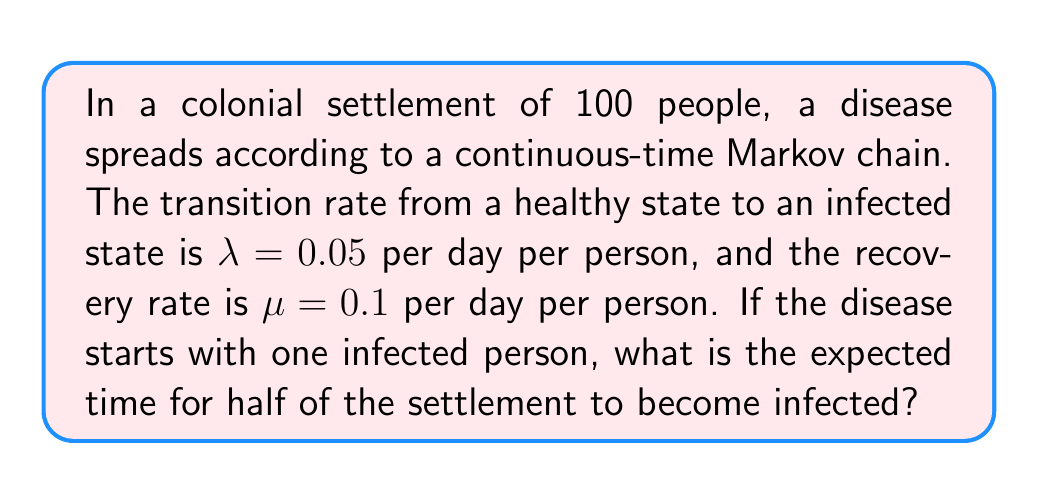Can you answer this question? To solve this problem, we'll use the SIS (Susceptible-Infected-Susceptible) model in epidemiology:

1) First, we need to find the equilibrium point of the infection. In the SIS model, the equilibrium occurs when:

   $$\frac{\lambda}{\lambda + \mu} = \frac{I^*}{N}$$

   where $I^*$ is the equilibrium number of infected individuals and $N$ is the total population.

2) Substituting our values:

   $$\frac{0.05}{0.05 + 0.1} = \frac{I^*}{100}$$
   $$\frac{1}{3} = \frac{I^*}{100}$$
   $$I^* = 33.33$$

3) The equilibrium point is less than half the population, so the system will never reach 50 infected on average.

4) Instead, we can calculate the expected time to reach the equilibrium. The dynamics of the infection follow:

   $$\frac{dI}{dt} = \lambda S(t)I(t) - \mu I(t)$$

   where $S(t) = N - I(t)$ is the number of susceptible individuals.

5) Near the start of the epidemic, when $I$ is small, we can approximate this as:

   $$\frac{dI}{dt} \approx (\lambda N - \mu)I$$

6) This has the solution:

   $$I(t) = I(0)e^{(\lambda N - \mu)t}$$

7) The doubling time is given by:

   $$t_d = \frac{\ln(2)}{\lambda N - \mu}$$

8) Substituting our values:

   $$t_d = \frac{\ln(2)}{0.05 * 100 - 0.1} = 0.139 \text{ days}$$

9) To reach the equilibrium of 33.33 infected, we need about 5 doubling times:

   $$33.33 \approx 1 * 2^5$$

10) Therefore, the expected time to reach equilibrium is approximately:

    $$5 * 0.139 = 0.695 \text{ days}$$
Answer: 0.695 days 